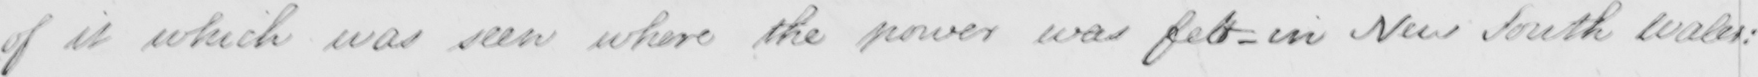Please provide the text content of this handwritten line. of it which was seen where the power was felt - in New South Wales : 